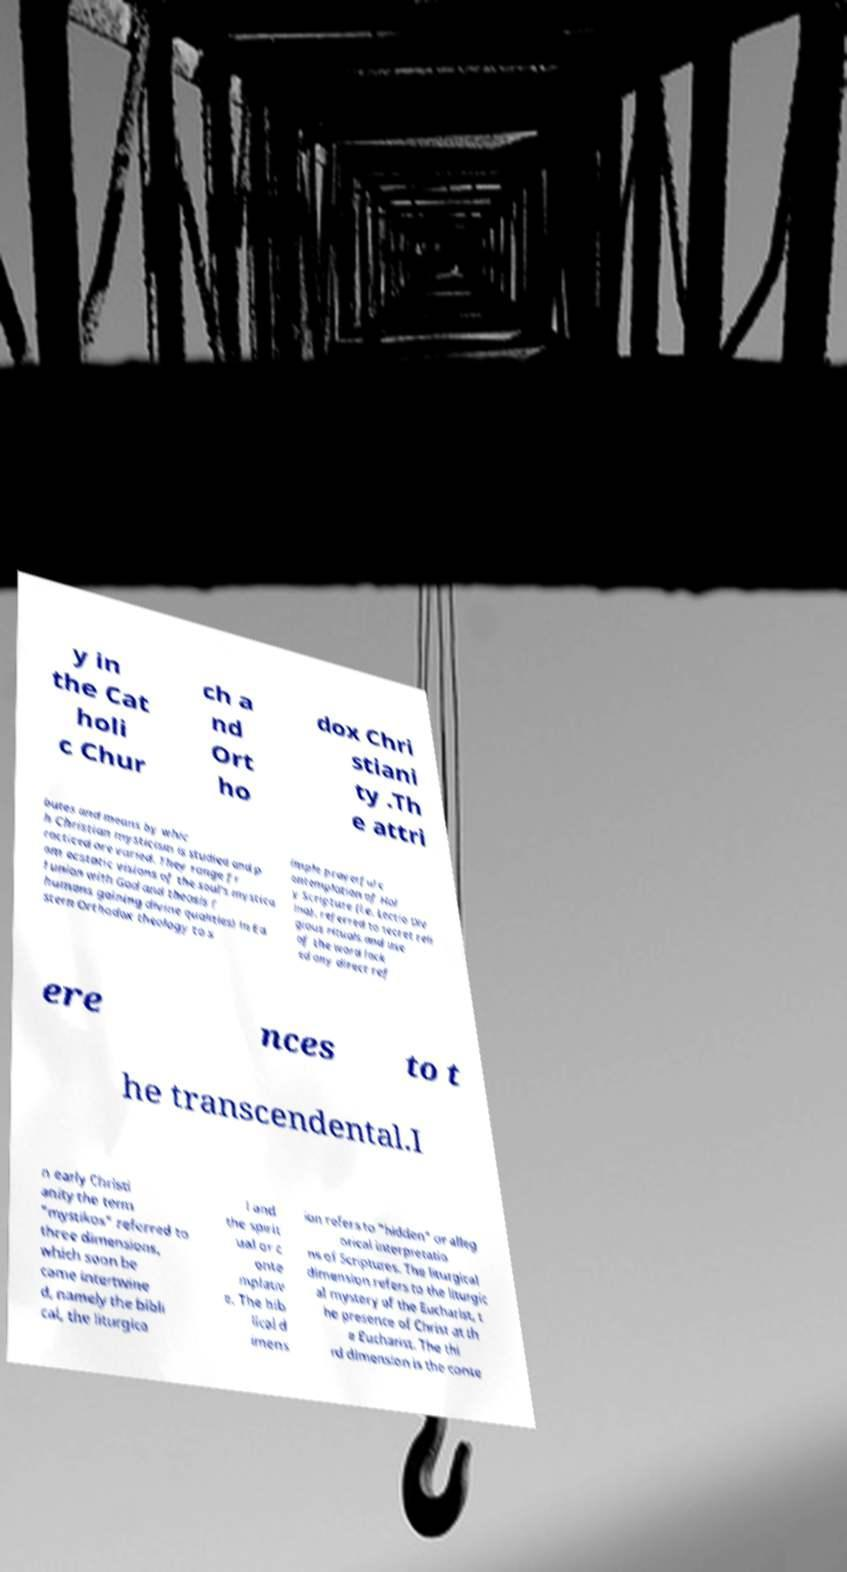There's text embedded in this image that I need extracted. Can you transcribe it verbatim? y in the Cat holi c Chur ch a nd Ort ho dox Chri stiani ty .Th e attri butes and means by whic h Christian mysticism is studied and p racticed are varied. They range fr om ecstatic visions of the soul's mystica l union with God and theosis ( humans gaining divine qualities) in Ea stern Orthodox theology to s imple prayerful c ontemplation of Hol y Scripture (i.e. Lectio Div ina). referred to secret reli gious rituals and use of the word lack ed any direct ref ere nces to t he transcendental.I n early Christi anity the term "mystikos" referred to three dimensions, which soon be came intertwine d, namely the bibli cal, the liturgica l and the spirit ual or c onte mplativ e. The bib lical d imens ion refers to "hidden" or alleg orical interpretatio ns of Scriptures. The liturgical dimension refers to the liturgic al mystery of the Eucharist, t he presence of Christ at th e Eucharist. The thi rd dimension is the conte 